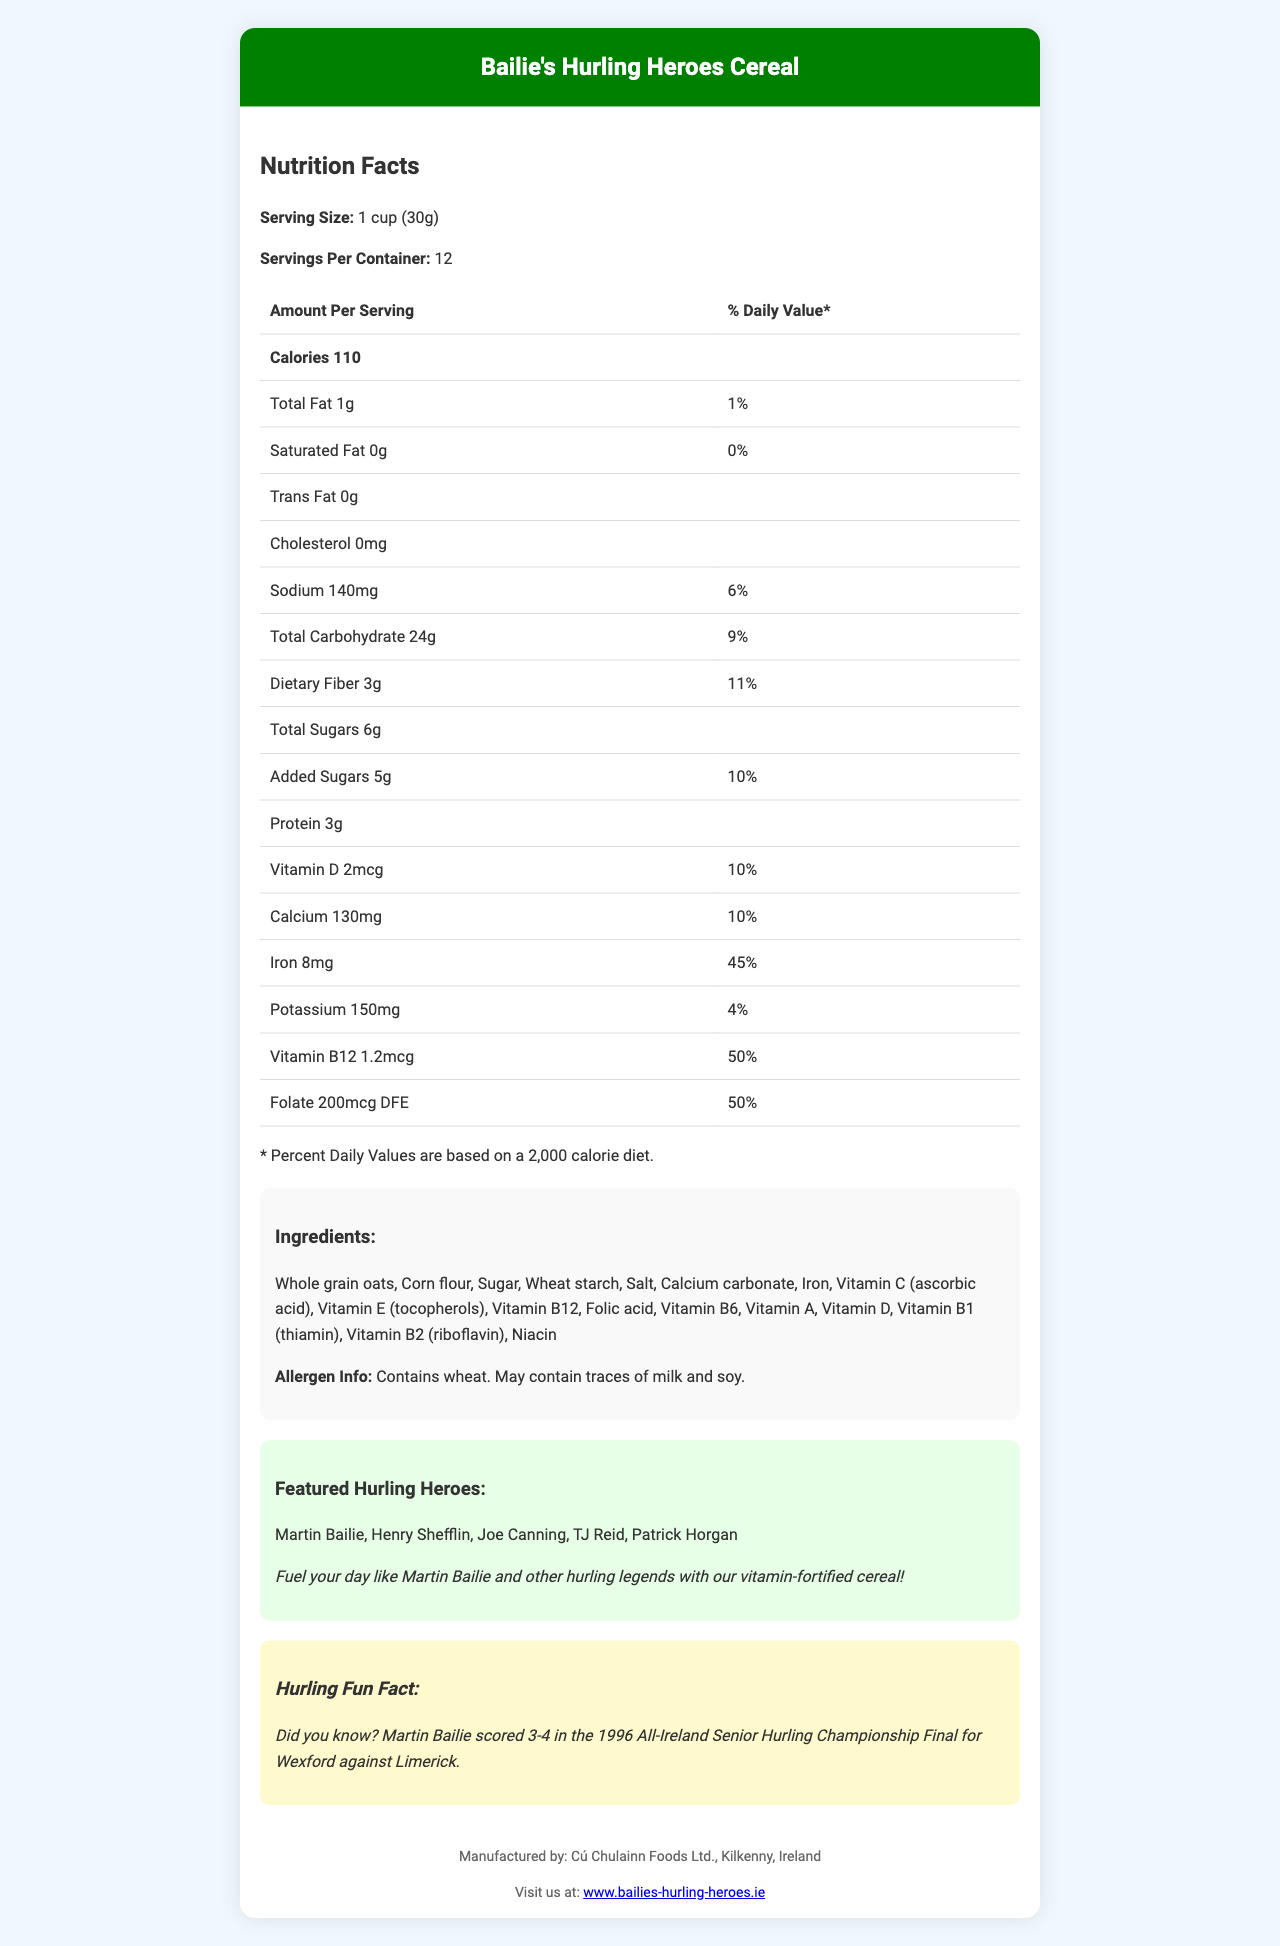what is the serving size for Bailie's Hurling Heroes Cereal? The serving size is mentioned directly under the "Nutrition Facts" heading.
Answer: 1 cup (30g) how many grams of dietary fiber are in one serving of the cereal? The amount of dietary fiber per serving is detailed in the "Dietary Fiber" row of the nutrition facts table.
Answer: 3g name one of the vitamins included in Bailie's Hurling Heroes Cereal and its daily value percentage. The document lists Vitamin D with a daily value of 10%.
Answer: Vitamin D, 10% what is the calorie content per serving? The calorie content per serving is listed in a bold format under the "Calories" row.
Answer: 110 how much sodium is in one serving of the cereal? The amount of sodium per serving is provided in the row labeled "Sodium."
Answer: 140mg which ingredient is listed first in the ingredient list? The ingredients are listed in order of predominance, with "Whole grain oats" being the first on the list.
Answer: Whole grain oats does the cereal contain any allergens? The allergen information section states that the cereal contains wheat and may contain traces of milk and soy.
Answer: Yes which vitamin has the highest daily value percentage in the cereal? A. Vitamin D B. Vitamin B12 C. Iron D. Folate Iron has the highest daily value percentage at 45%, followed by Folate and Vitamin B12 at 50% each.
Answer: C. Iron who is NOT a featured player on the cereal box? A. Martin Bailie B. Henry Shefflin C. Joe Canning D. Brian Lohan Brian Lohan is not listed among the featured players; the other names are listed.
Answer: D. Brian Lohan is there any trans fat in a serving of Bailie's Hurling Heroes Cereal? The document indicates "Trans Fat 0g" in the nutrition facts table.
Answer: No briefly summarize what this document is about The document gives a comprehensive overview of the cereal's nutritional value, ingredients, featured athletes, and additional fun and promotional information.
Answer: This document is a nutrition facts label for Bailie's Hurling Heroes Cereal. It includes detailed nutritional information per serving, ingredient and allergen lists, features hurling players like Martin Bailie, and provides a fun fact about Martin Bailie's career. The manufacturer and website information are also provided. was Martin Bailie the top scorer in the 1996 All-Ireland Senior Hurling Championship Final? The document mentions that Martin Bailie scored 3-4 in the final, but it does not specify if he was the top scorer.
Answer: Cannot be determined 